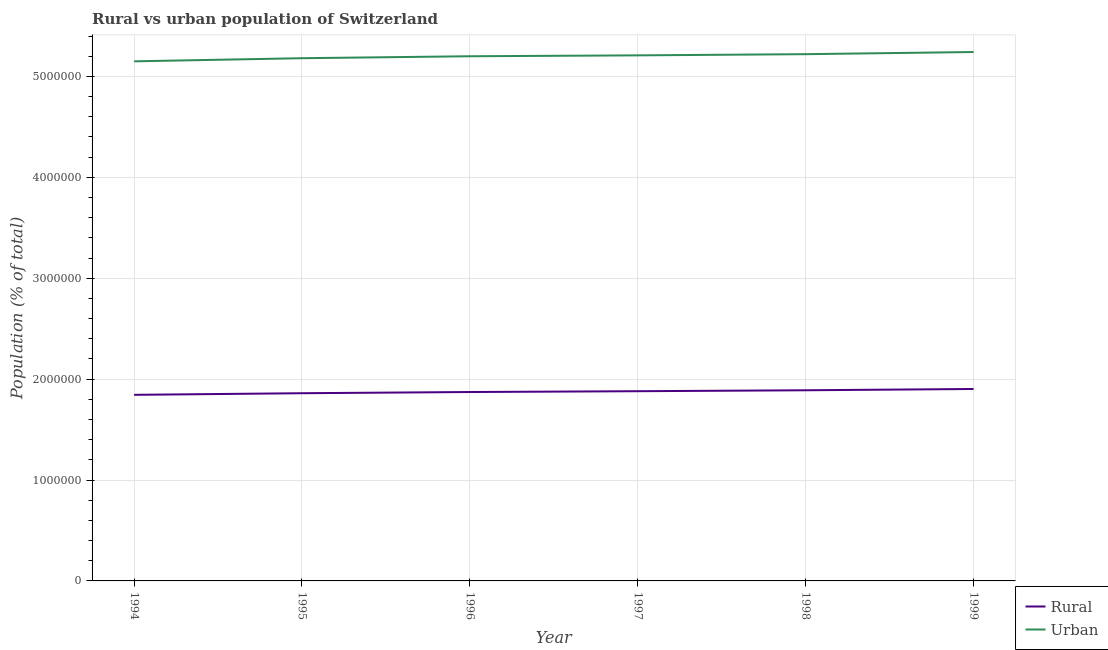Does the line corresponding to urban population density intersect with the line corresponding to rural population density?
Provide a succinct answer. No. What is the urban population density in 1998?
Offer a very short reply. 5.22e+06. Across all years, what is the maximum rural population density?
Ensure brevity in your answer.  1.90e+06. Across all years, what is the minimum urban population density?
Make the answer very short. 5.15e+06. In which year was the rural population density minimum?
Your response must be concise. 1994. What is the total urban population density in the graph?
Provide a succinct answer. 3.12e+07. What is the difference between the urban population density in 1994 and that in 1998?
Keep it short and to the point. -7.10e+04. What is the difference between the urban population density in 1994 and the rural population density in 1996?
Give a very brief answer. 3.28e+06. What is the average urban population density per year?
Keep it short and to the point. 5.20e+06. In the year 1998, what is the difference between the urban population density and rural population density?
Keep it short and to the point. 3.33e+06. What is the ratio of the rural population density in 1994 to that in 1996?
Provide a succinct answer. 0.99. Is the rural population density in 1995 less than that in 1996?
Offer a very short reply. Yes. Is the difference between the rural population density in 1995 and 1997 greater than the difference between the urban population density in 1995 and 1997?
Offer a very short reply. Yes. What is the difference between the highest and the second highest rural population density?
Offer a terse response. 1.27e+04. What is the difference between the highest and the lowest rural population density?
Provide a succinct answer. 5.79e+04. Is the sum of the rural population density in 1995 and 1996 greater than the maximum urban population density across all years?
Your answer should be very brief. No. Is the rural population density strictly greater than the urban population density over the years?
Make the answer very short. No. Is the rural population density strictly less than the urban population density over the years?
Offer a terse response. Yes. How many lines are there?
Keep it short and to the point. 2. Does the graph contain grids?
Make the answer very short. Yes. Where does the legend appear in the graph?
Provide a short and direct response. Bottom right. How are the legend labels stacked?
Your answer should be compact. Vertical. What is the title of the graph?
Your answer should be compact. Rural vs urban population of Switzerland. What is the label or title of the Y-axis?
Offer a very short reply. Population (% of total). What is the Population (% of total) of Rural in 1994?
Offer a very short reply. 1.84e+06. What is the Population (% of total) of Urban in 1994?
Your answer should be very brief. 5.15e+06. What is the Population (% of total) in Rural in 1995?
Your answer should be compact. 1.86e+06. What is the Population (% of total) in Urban in 1995?
Make the answer very short. 5.18e+06. What is the Population (% of total) of Rural in 1996?
Offer a terse response. 1.87e+06. What is the Population (% of total) of Urban in 1996?
Ensure brevity in your answer.  5.20e+06. What is the Population (% of total) in Rural in 1997?
Provide a succinct answer. 1.88e+06. What is the Population (% of total) in Urban in 1997?
Offer a terse response. 5.21e+06. What is the Population (% of total) of Rural in 1998?
Your answer should be very brief. 1.89e+06. What is the Population (% of total) in Urban in 1998?
Offer a very short reply. 5.22e+06. What is the Population (% of total) of Rural in 1999?
Offer a terse response. 1.90e+06. What is the Population (% of total) of Urban in 1999?
Offer a very short reply. 5.24e+06. Across all years, what is the maximum Population (% of total) in Rural?
Provide a succinct answer. 1.90e+06. Across all years, what is the maximum Population (% of total) of Urban?
Provide a succinct answer. 5.24e+06. Across all years, what is the minimum Population (% of total) in Rural?
Offer a very short reply. 1.84e+06. Across all years, what is the minimum Population (% of total) in Urban?
Ensure brevity in your answer.  5.15e+06. What is the total Population (% of total) in Rural in the graph?
Your response must be concise. 1.12e+07. What is the total Population (% of total) in Urban in the graph?
Offer a terse response. 3.12e+07. What is the difference between the Population (% of total) of Rural in 1994 and that in 1995?
Give a very brief answer. -1.60e+04. What is the difference between the Population (% of total) of Urban in 1994 and that in 1995?
Ensure brevity in your answer.  -3.09e+04. What is the difference between the Population (% of total) of Rural in 1994 and that in 1996?
Offer a very short reply. -2.78e+04. What is the difference between the Population (% of total) of Urban in 1994 and that in 1996?
Offer a very short reply. -5.03e+04. What is the difference between the Population (% of total) of Rural in 1994 and that in 1997?
Your response must be concise. -3.59e+04. What is the difference between the Population (% of total) in Urban in 1994 and that in 1997?
Make the answer very short. -5.92e+04. What is the difference between the Population (% of total) of Rural in 1994 and that in 1998?
Ensure brevity in your answer.  -4.52e+04. What is the difference between the Population (% of total) of Urban in 1994 and that in 1998?
Make the answer very short. -7.10e+04. What is the difference between the Population (% of total) in Rural in 1994 and that in 1999?
Ensure brevity in your answer.  -5.79e+04. What is the difference between the Population (% of total) in Urban in 1994 and that in 1999?
Give a very brief answer. -9.23e+04. What is the difference between the Population (% of total) in Rural in 1995 and that in 1996?
Provide a short and direct response. -1.18e+04. What is the difference between the Population (% of total) in Urban in 1995 and that in 1996?
Provide a short and direct response. -1.93e+04. What is the difference between the Population (% of total) in Rural in 1995 and that in 1997?
Make the answer very short. -2.00e+04. What is the difference between the Population (% of total) of Urban in 1995 and that in 1997?
Your response must be concise. -2.82e+04. What is the difference between the Population (% of total) of Rural in 1995 and that in 1998?
Provide a short and direct response. -2.93e+04. What is the difference between the Population (% of total) in Urban in 1995 and that in 1998?
Your response must be concise. -4.00e+04. What is the difference between the Population (% of total) of Rural in 1995 and that in 1999?
Make the answer very short. -4.19e+04. What is the difference between the Population (% of total) of Urban in 1995 and that in 1999?
Offer a very short reply. -6.14e+04. What is the difference between the Population (% of total) of Rural in 1996 and that in 1997?
Offer a terse response. -8130. What is the difference between the Population (% of total) in Urban in 1996 and that in 1997?
Your answer should be very brief. -8926. What is the difference between the Population (% of total) in Rural in 1996 and that in 1998?
Ensure brevity in your answer.  -1.74e+04. What is the difference between the Population (% of total) of Urban in 1996 and that in 1998?
Offer a terse response. -2.07e+04. What is the difference between the Population (% of total) of Rural in 1996 and that in 1999?
Your answer should be very brief. -3.01e+04. What is the difference between the Population (% of total) in Urban in 1996 and that in 1999?
Give a very brief answer. -4.20e+04. What is the difference between the Population (% of total) in Rural in 1997 and that in 1998?
Offer a very short reply. -9293. What is the difference between the Population (% of total) in Urban in 1997 and that in 1998?
Your response must be concise. -1.18e+04. What is the difference between the Population (% of total) in Rural in 1997 and that in 1999?
Your response must be concise. -2.20e+04. What is the difference between the Population (% of total) of Urban in 1997 and that in 1999?
Your response must be concise. -3.31e+04. What is the difference between the Population (% of total) in Rural in 1998 and that in 1999?
Ensure brevity in your answer.  -1.27e+04. What is the difference between the Population (% of total) of Urban in 1998 and that in 1999?
Your answer should be very brief. -2.13e+04. What is the difference between the Population (% of total) of Rural in 1994 and the Population (% of total) of Urban in 1995?
Provide a short and direct response. -3.34e+06. What is the difference between the Population (% of total) of Rural in 1994 and the Population (% of total) of Urban in 1996?
Provide a short and direct response. -3.36e+06. What is the difference between the Population (% of total) in Rural in 1994 and the Population (% of total) in Urban in 1997?
Offer a very short reply. -3.36e+06. What is the difference between the Population (% of total) of Rural in 1994 and the Population (% of total) of Urban in 1998?
Keep it short and to the point. -3.38e+06. What is the difference between the Population (% of total) in Rural in 1994 and the Population (% of total) in Urban in 1999?
Your answer should be very brief. -3.40e+06. What is the difference between the Population (% of total) in Rural in 1995 and the Population (% of total) in Urban in 1996?
Give a very brief answer. -3.34e+06. What is the difference between the Population (% of total) of Rural in 1995 and the Population (% of total) of Urban in 1997?
Provide a short and direct response. -3.35e+06. What is the difference between the Population (% of total) of Rural in 1995 and the Population (% of total) of Urban in 1998?
Provide a succinct answer. -3.36e+06. What is the difference between the Population (% of total) in Rural in 1995 and the Population (% of total) in Urban in 1999?
Give a very brief answer. -3.38e+06. What is the difference between the Population (% of total) in Rural in 1996 and the Population (% of total) in Urban in 1997?
Your answer should be compact. -3.34e+06. What is the difference between the Population (% of total) in Rural in 1996 and the Population (% of total) in Urban in 1998?
Make the answer very short. -3.35e+06. What is the difference between the Population (% of total) in Rural in 1996 and the Population (% of total) in Urban in 1999?
Ensure brevity in your answer.  -3.37e+06. What is the difference between the Population (% of total) of Rural in 1997 and the Population (% of total) of Urban in 1998?
Provide a short and direct response. -3.34e+06. What is the difference between the Population (% of total) in Rural in 1997 and the Population (% of total) in Urban in 1999?
Provide a short and direct response. -3.36e+06. What is the difference between the Population (% of total) of Rural in 1998 and the Population (% of total) of Urban in 1999?
Your response must be concise. -3.35e+06. What is the average Population (% of total) of Rural per year?
Offer a terse response. 1.87e+06. What is the average Population (% of total) in Urban per year?
Your answer should be compact. 5.20e+06. In the year 1994, what is the difference between the Population (% of total) of Rural and Population (% of total) of Urban?
Offer a very short reply. -3.31e+06. In the year 1995, what is the difference between the Population (% of total) in Rural and Population (% of total) in Urban?
Keep it short and to the point. -3.32e+06. In the year 1996, what is the difference between the Population (% of total) in Rural and Population (% of total) in Urban?
Give a very brief answer. -3.33e+06. In the year 1997, what is the difference between the Population (% of total) of Rural and Population (% of total) of Urban?
Your answer should be very brief. -3.33e+06. In the year 1998, what is the difference between the Population (% of total) of Rural and Population (% of total) of Urban?
Your answer should be compact. -3.33e+06. In the year 1999, what is the difference between the Population (% of total) of Rural and Population (% of total) of Urban?
Provide a short and direct response. -3.34e+06. What is the ratio of the Population (% of total) of Rural in 1994 to that in 1996?
Give a very brief answer. 0.99. What is the ratio of the Population (% of total) of Urban in 1994 to that in 1996?
Make the answer very short. 0.99. What is the ratio of the Population (% of total) in Rural in 1994 to that in 1997?
Your response must be concise. 0.98. What is the ratio of the Population (% of total) in Urban in 1994 to that in 1997?
Ensure brevity in your answer.  0.99. What is the ratio of the Population (% of total) in Rural in 1994 to that in 1998?
Provide a succinct answer. 0.98. What is the ratio of the Population (% of total) in Urban in 1994 to that in 1998?
Your answer should be very brief. 0.99. What is the ratio of the Population (% of total) in Rural in 1994 to that in 1999?
Provide a short and direct response. 0.97. What is the ratio of the Population (% of total) in Urban in 1994 to that in 1999?
Provide a succinct answer. 0.98. What is the ratio of the Population (% of total) of Urban in 1995 to that in 1996?
Your response must be concise. 1. What is the ratio of the Population (% of total) of Rural in 1995 to that in 1997?
Make the answer very short. 0.99. What is the ratio of the Population (% of total) in Urban in 1995 to that in 1997?
Your answer should be compact. 0.99. What is the ratio of the Population (% of total) in Rural in 1995 to that in 1998?
Make the answer very short. 0.98. What is the ratio of the Population (% of total) of Urban in 1995 to that in 1998?
Your answer should be very brief. 0.99. What is the ratio of the Population (% of total) in Rural in 1995 to that in 1999?
Your response must be concise. 0.98. What is the ratio of the Population (% of total) of Urban in 1995 to that in 1999?
Offer a very short reply. 0.99. What is the ratio of the Population (% of total) of Rural in 1996 to that in 1997?
Make the answer very short. 1. What is the ratio of the Population (% of total) in Urban in 1996 to that in 1998?
Ensure brevity in your answer.  1. What is the ratio of the Population (% of total) in Rural in 1996 to that in 1999?
Give a very brief answer. 0.98. What is the ratio of the Population (% of total) in Urban in 1996 to that in 1999?
Make the answer very short. 0.99. What is the ratio of the Population (% of total) of Rural in 1998 to that in 1999?
Your response must be concise. 0.99. What is the ratio of the Population (% of total) of Urban in 1998 to that in 1999?
Make the answer very short. 1. What is the difference between the highest and the second highest Population (% of total) in Rural?
Your answer should be compact. 1.27e+04. What is the difference between the highest and the second highest Population (% of total) of Urban?
Offer a very short reply. 2.13e+04. What is the difference between the highest and the lowest Population (% of total) of Rural?
Offer a very short reply. 5.79e+04. What is the difference between the highest and the lowest Population (% of total) of Urban?
Offer a terse response. 9.23e+04. 